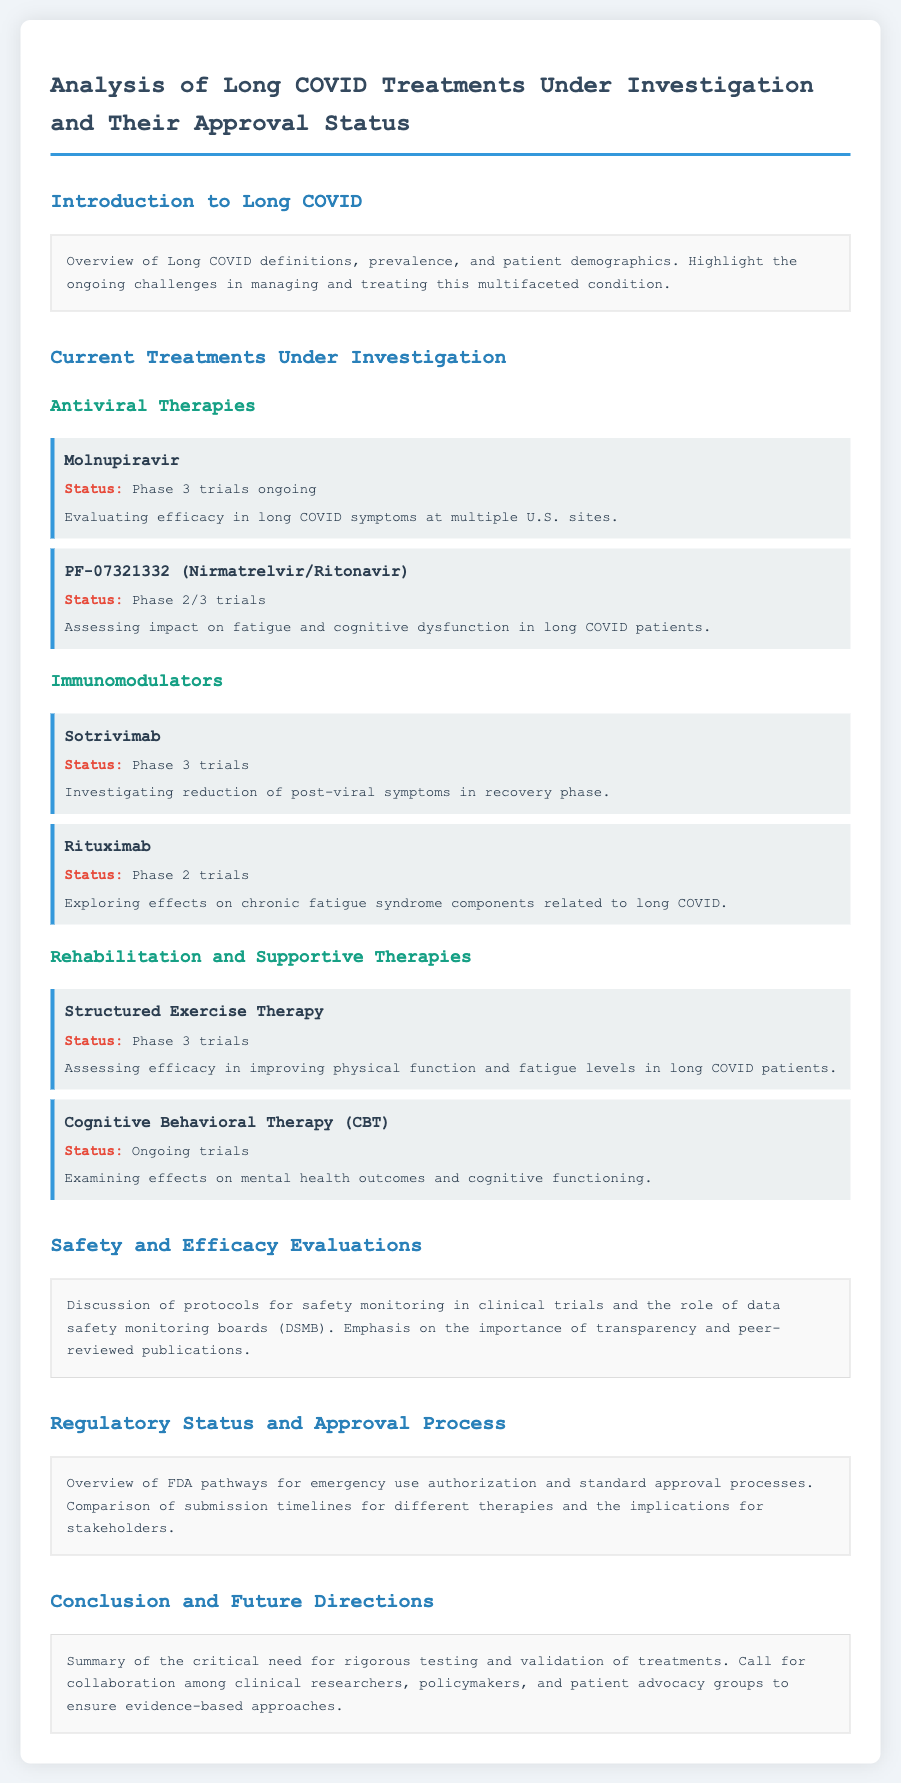What is the status of Molnupiravir? The status of Molnupiravir is detailed in the document as being in Phase 3 trials.
Answer: Phase 3 trials ongoing What is the focus of PF-07321332 trials? The document specifies that PF-07321332 is assessing the impact on fatigue and cognitive dysfunction in long COVID patients.
Answer: Fatigue and cognitive dysfunction What phase are the trials for Rituximab? The document states that Rituximab is currently in Phase 2 trials.
Answer: Phase 2 trials Which therapy is investigating the reduction of post-viral symptoms? The document mentions Sotrivimab as the therapy investigating the reduction of post-viral symptoms in recovery phase.
Answer: Sotrivimab What is the primary objective of Structured Exercise Therapy trials? According to the document, the primary objective is assessing efficacy in improving physical function and fatigue levels in long COVID patients.
Answer: Improving physical function and fatigue levels What type of therapy is Cognitive Behavioral Therapy classified as? The document classifies Cognitive Behavioral Therapy as a supportive therapy under ongoing trials examining mental health outcomes.
Answer: Supportive therapy What is the overarching theme discussed in the Conclusion and Future Directions section? The Conclusion emphasizes the need for rigorous testing and validation of treatments for long COVID.
Answer: Rigorous testing and validation What role do data safety monitoring boards (DSMB) play in the trials? The document discusses the importance of data safety monitoring boards (DSMB) in safety monitoring during clinical trials.
Answer: Safety monitoring Which treatments are in Phase 3 trials according to the document? The treatments mentioned in Phase 3 trials include Molnupiravir, Sotrivimab, and Structured Exercise Therapy.
Answer: Molnupiravir, Sotrivimab, Structured Exercise Therapy 